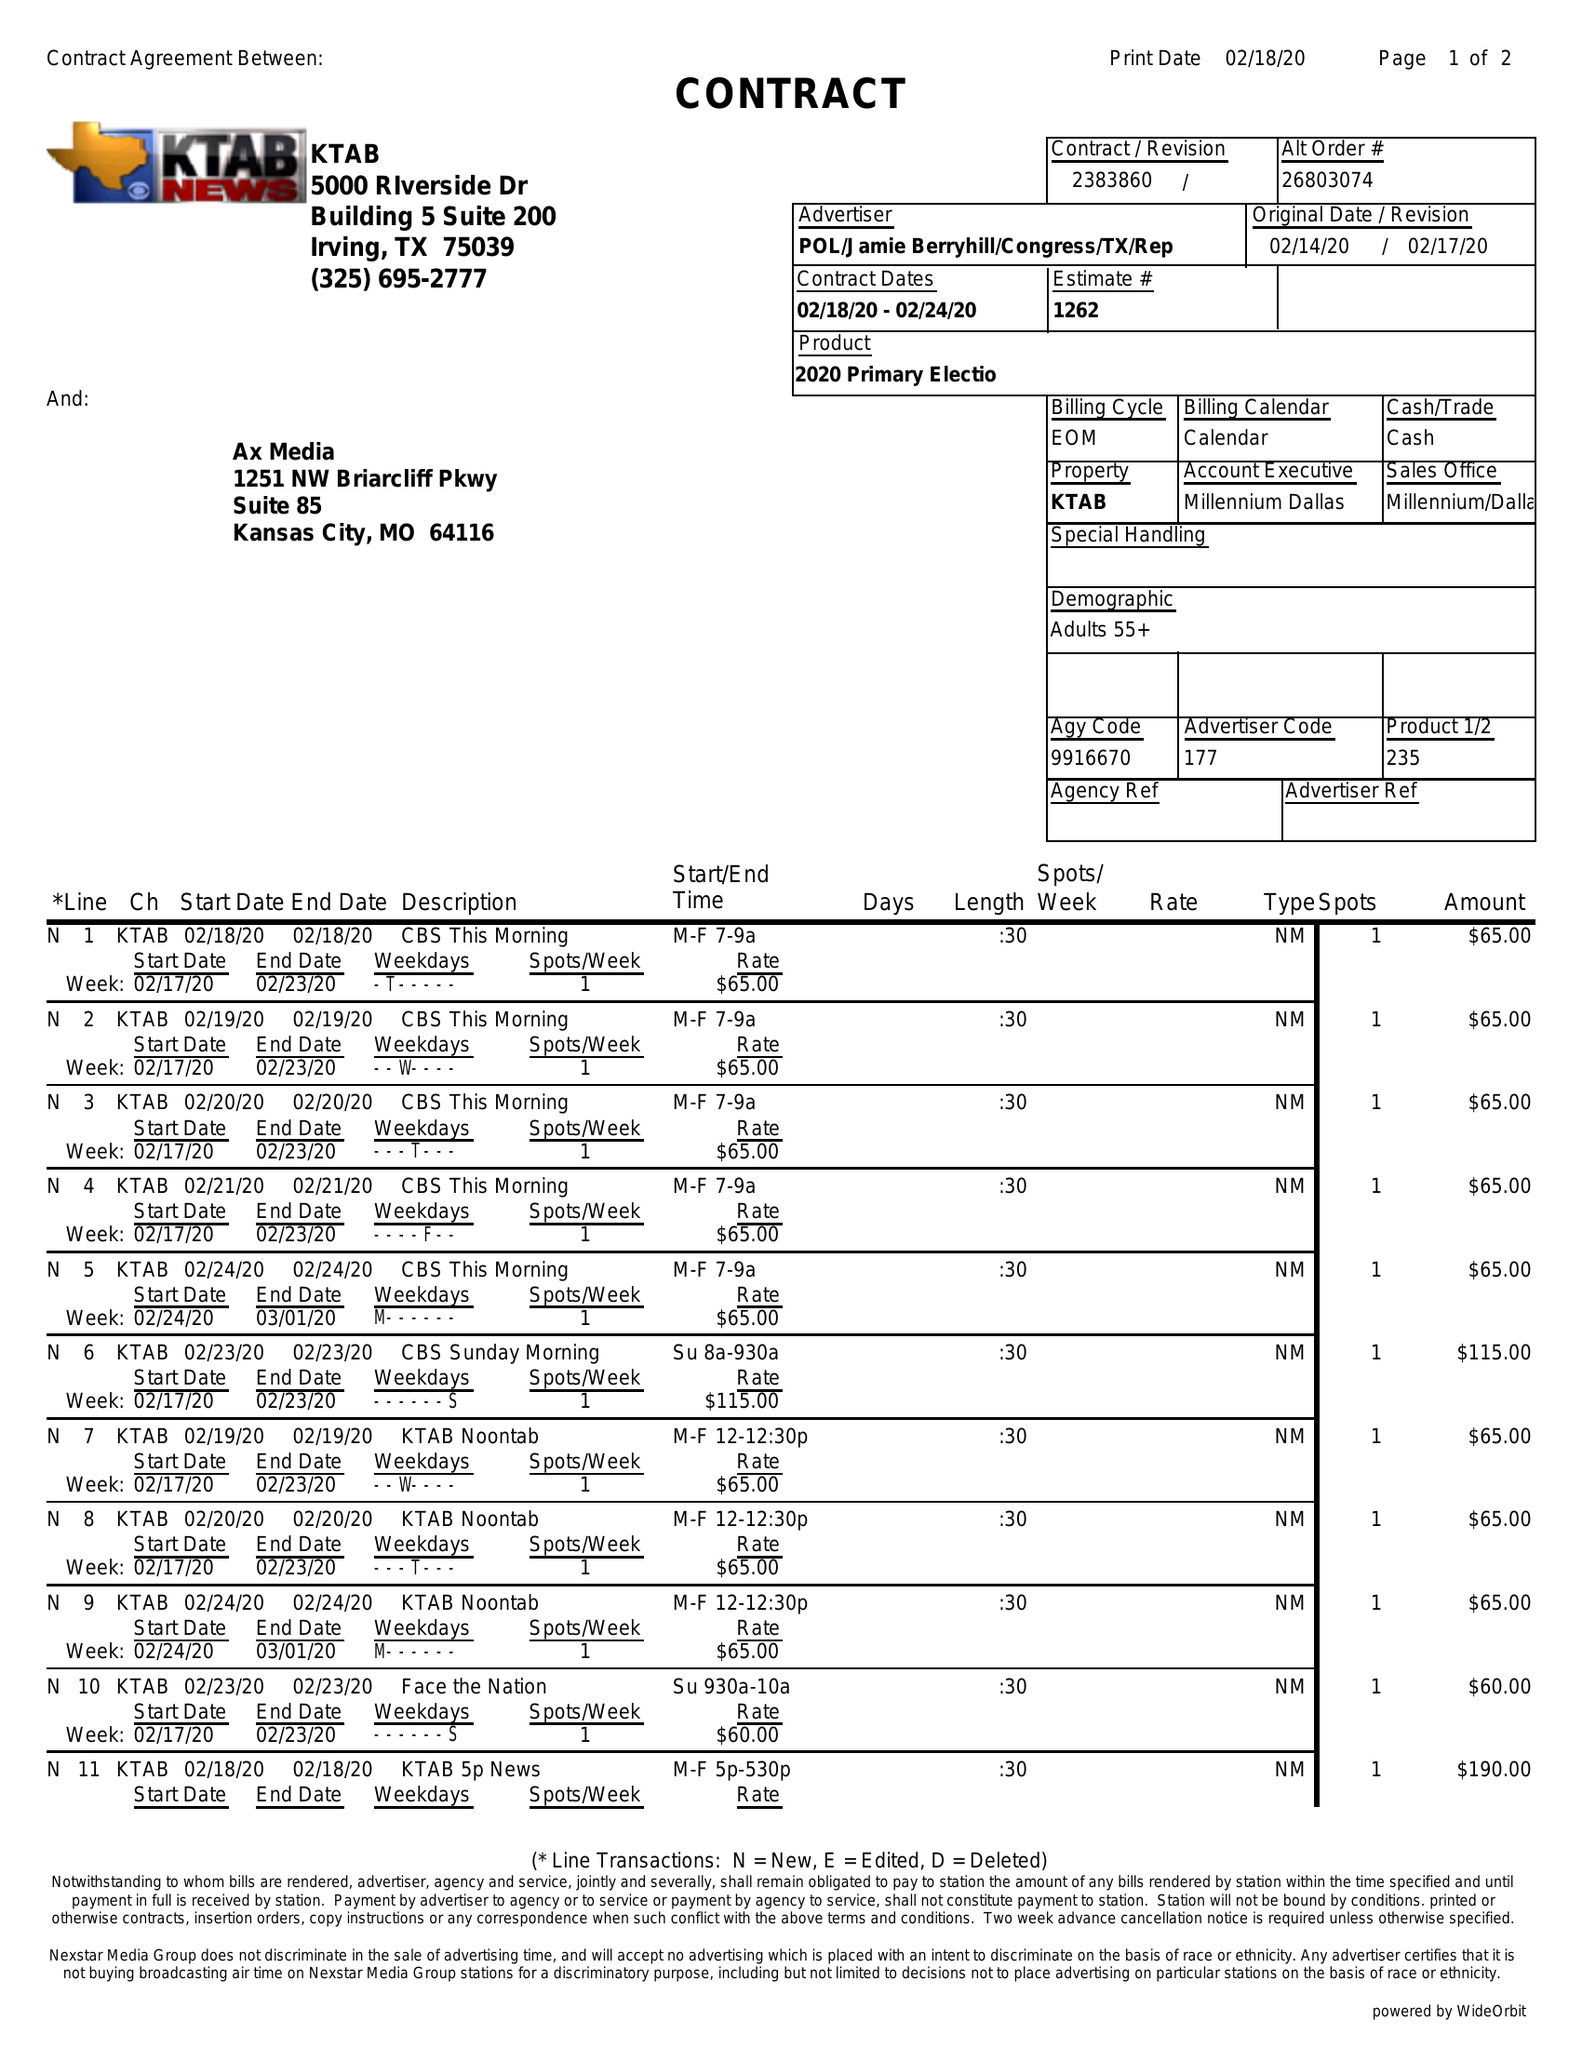What is the value for the gross_amount?
Answer the question using a single word or phrase. 4385.00 